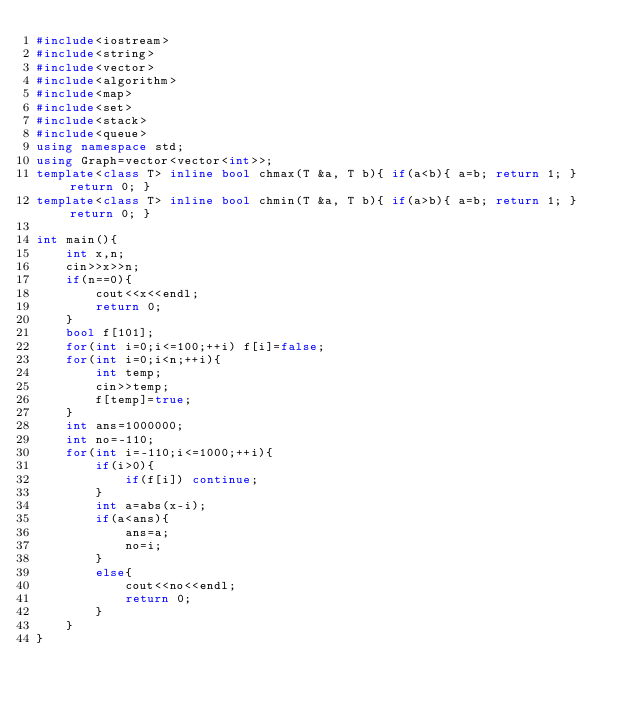Convert code to text. <code><loc_0><loc_0><loc_500><loc_500><_C++_>#include<iostream>
#include<string>
#include<vector>
#include<algorithm>
#include<map>
#include<set>
#include<stack>
#include<queue>
using namespace std;
using Graph=vector<vector<int>>;
template<class T> inline bool chmax(T &a, T b){ if(a<b){ a=b; return 1; } return 0; }
template<class T> inline bool chmin(T &a, T b){ if(a>b){ a=b; return 1; } return 0; }

int main(){
    int x,n;
    cin>>x>>n;
    if(n==0){
        cout<<x<<endl;
        return 0;
    }
    bool f[101];
    for(int i=0;i<=100;++i) f[i]=false;
    for(int i=0;i<n;++i){
        int temp;
        cin>>temp;
        f[temp]=true;
    }
    int ans=1000000;
    int no=-110;
    for(int i=-110;i<=1000;++i){
        if(i>0){
            if(f[i]) continue;
        }
        int a=abs(x-i);
        if(a<ans){
            ans=a;
            no=i;
        }
        else{
            cout<<no<<endl;
            return 0;
        }
    }
}</code> 